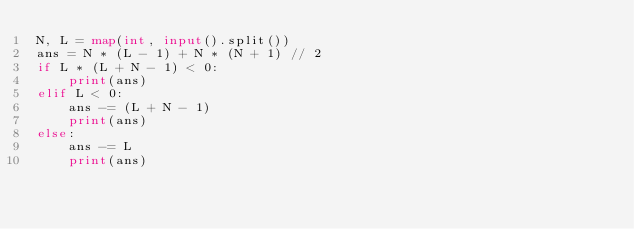Convert code to text. <code><loc_0><loc_0><loc_500><loc_500><_Python_>N, L = map(int, input().split())
ans = N * (L - 1) + N * (N + 1) // 2
if L * (L + N - 1) < 0:
    print(ans)
elif L < 0:
    ans -= (L + N - 1)
    print(ans)
else:
    ans -= L
    print(ans)
</code> 